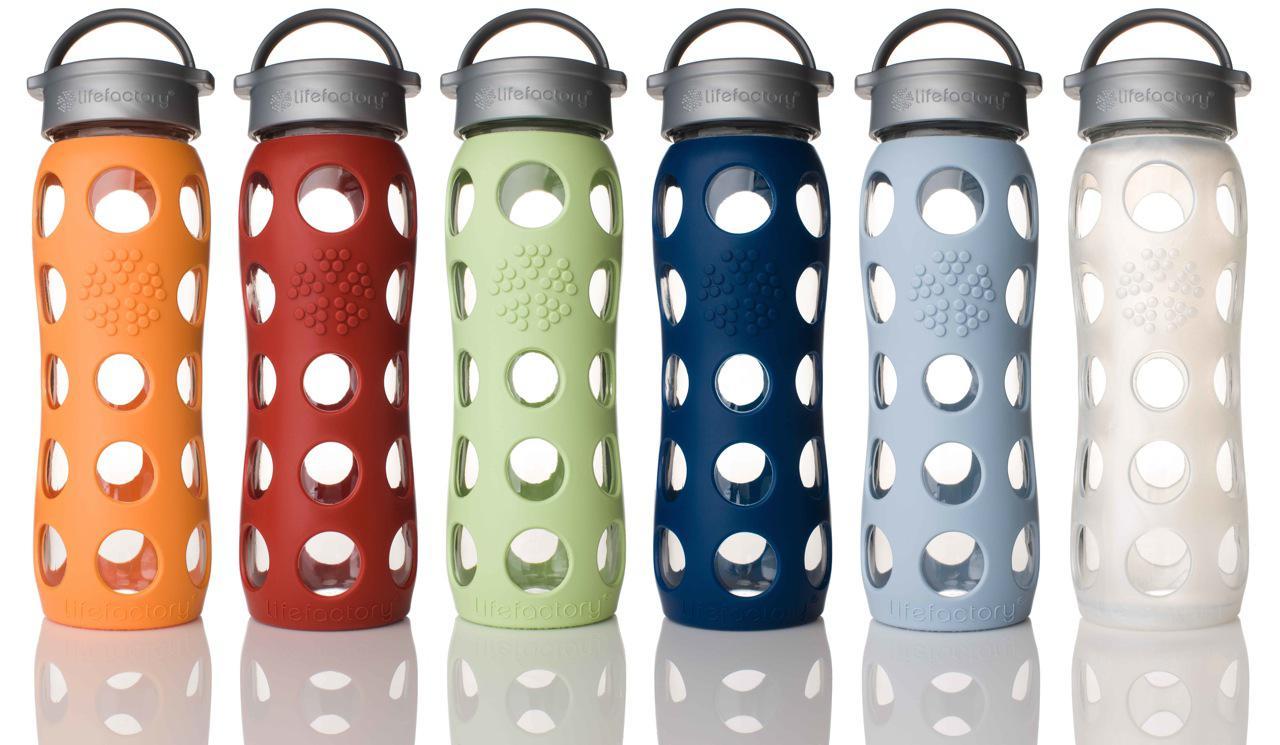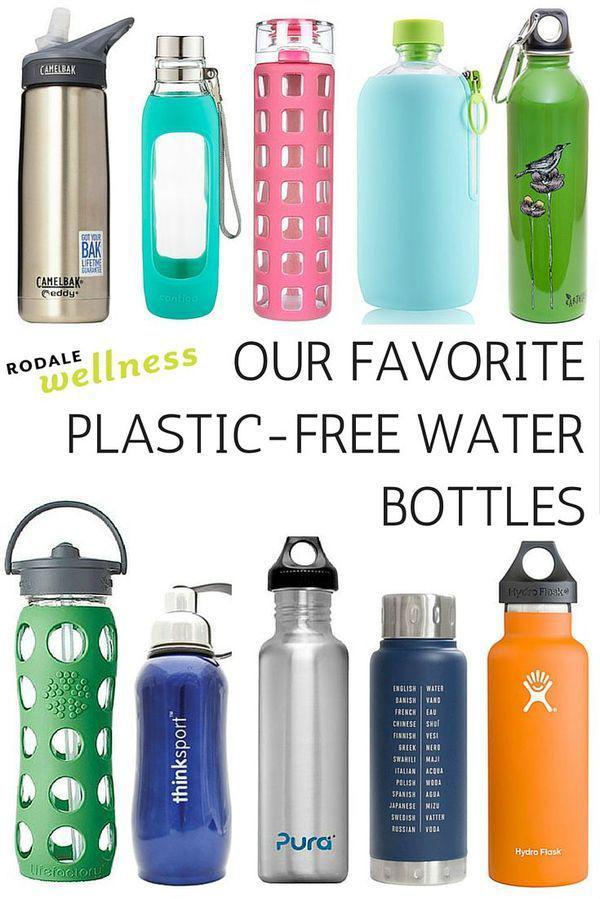The first image is the image on the left, the second image is the image on the right. Examine the images to the left and right. Is the description "One image is of many rows of plastic water bottles with plastic caps." accurate? Answer yes or no. No. The first image is the image on the left, the second image is the image on the right. Considering the images on both sides, is "The right image depicts refillable sport-type water bottles." valid? Answer yes or no. Yes. 